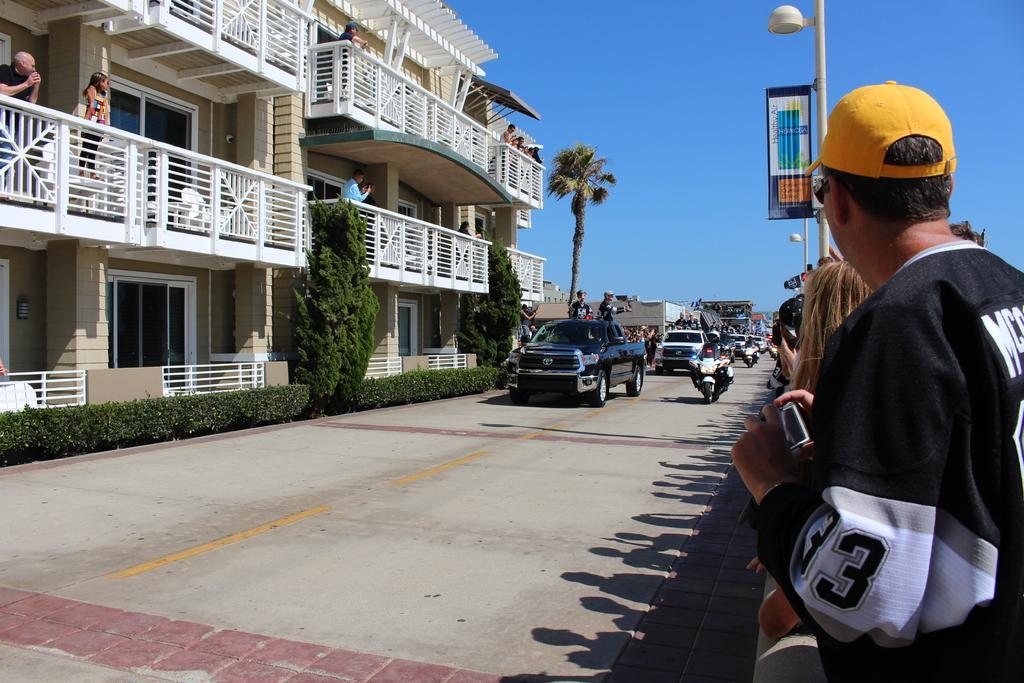Can you describe this image briefly? In this picture there is a man who is riding a bike, beside him there is a black car. Behind him I can see many people who are riding a bike and cars. On the left I can see the trees, plants, building, doors, railing and windows. In the background I can see the coconut tree and many buildings. On the right I can see the group of persons who are standing near to the street light and poster. At the top I can see the sky. In the top left I can see some people who are standing in the balcony. 